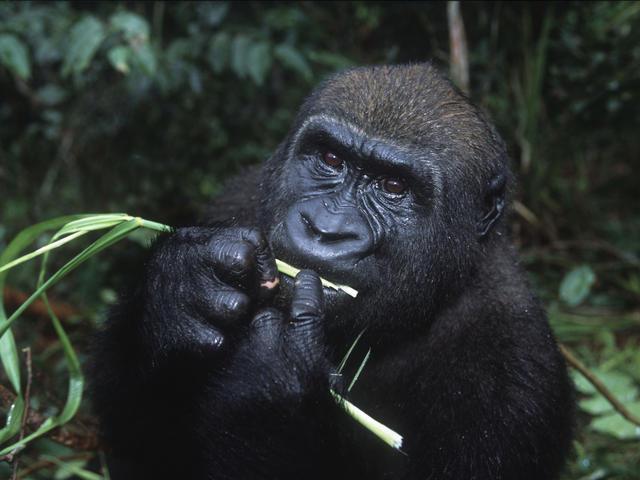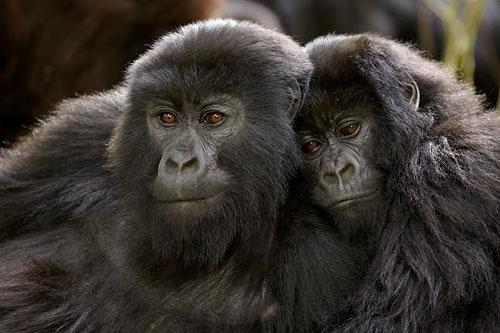The first image is the image on the left, the second image is the image on the right. Evaluate the accuracy of this statement regarding the images: "The right image shows exactly two apes, posed with their heads horizontal to one another.". Is it true? Answer yes or no. Yes. The first image is the image on the left, the second image is the image on the right. For the images displayed, is the sentence "There are two animals in the image on the left." factually correct? Answer yes or no. No. 